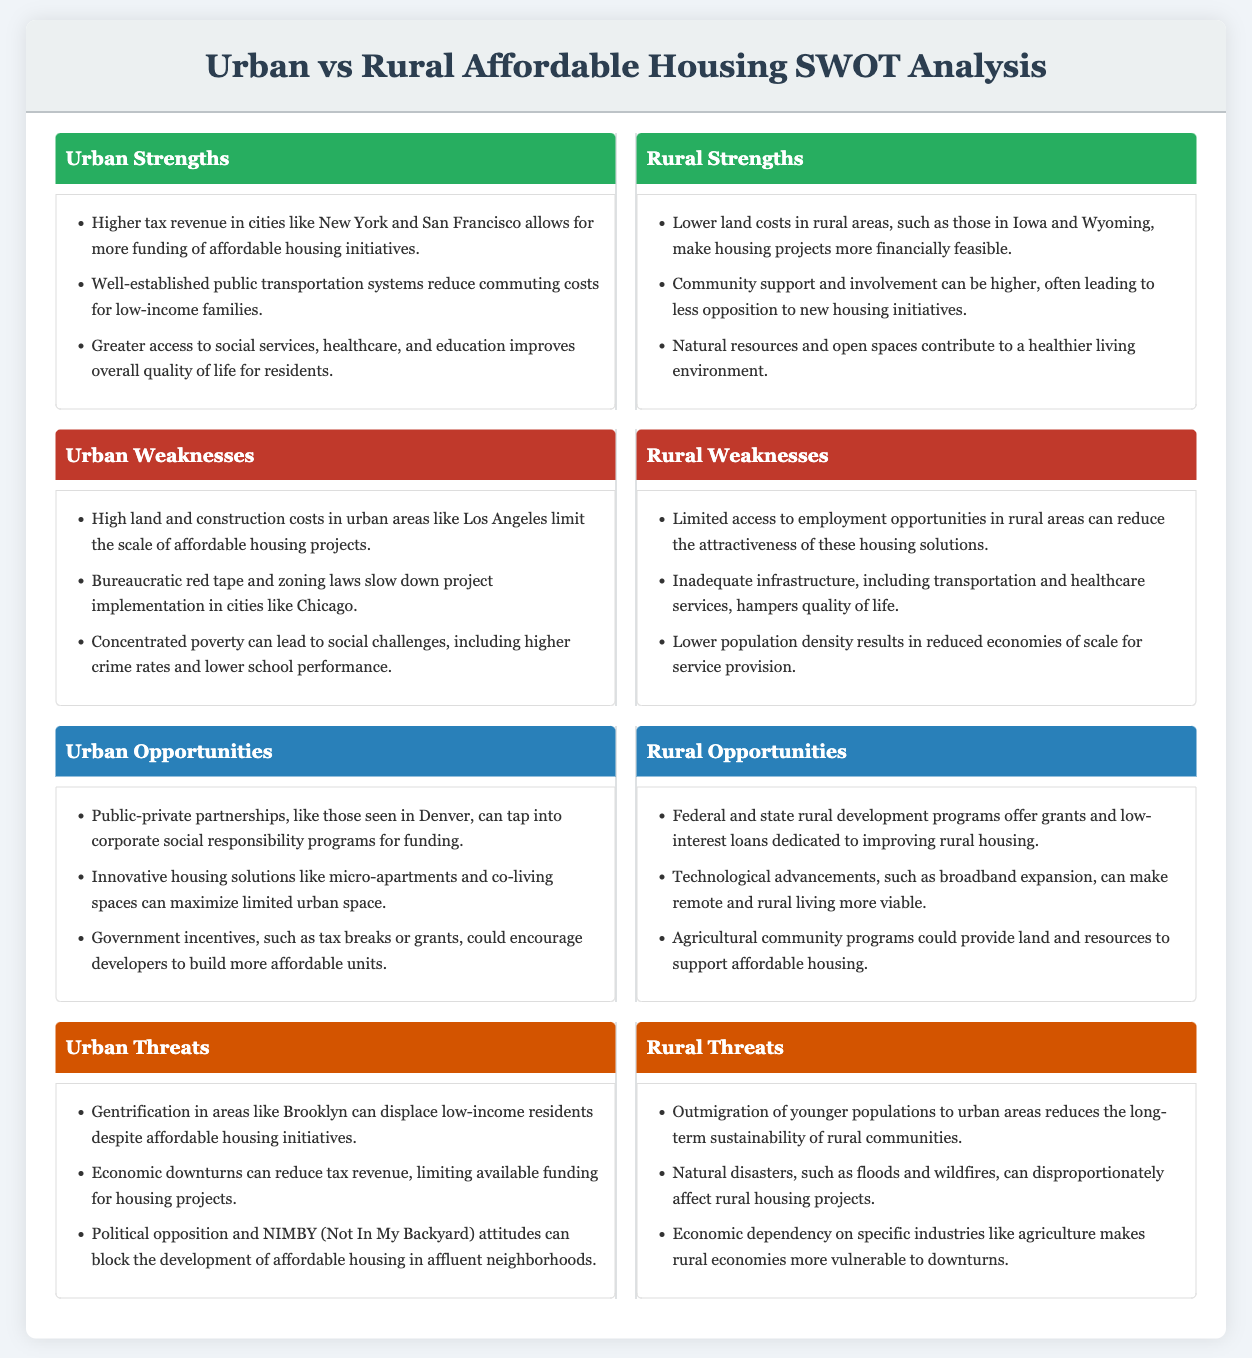What are the strengths of urban areas in affordable housing? The strengths listed under urban areas include higher tax revenue, well-established public transportation, and greater access to social services.
Answer: Higher tax revenue in cities like New York and San Francisco allows for more funding of affordable housing initiatives, well-established public transportation systems reduce commuting costs for low-income families, and greater access to social services, healthcare, and education improves overall quality of life for residents What is a weakness of rural housing initiatives? The weaknesses mentioned for rural areas include limited access to employment opportunities and inadequate infrastructure.
Answer: Limited access to employment opportunities in rural areas can reduce the attractiveness of these housing solutions What urban opportunity can improve affordable housing? The document lists several opportunities for urban areas, including public-private partnerships and innovative housing solutions.
Answer: Public-private partnerships, like those seen in Denver, can tap into corporate social responsibility programs for funding What is a threat faced by urban affordable housing projects? The threats listed for urban areas include gentrification, economic downturns, and political opposition.
Answer: Gentrification in areas like Brooklyn can displace low-income residents despite affordable housing initiatives Which rural strength supports housing initiatives? The strengths associated with rural housing initiatives include lower land costs and community support.
Answer: Lower land costs in rural areas, such as those in Iowa and Wyoming, make housing projects more financially feasible What role does technology play in rural housing opportunities? The opportunities for rural areas include technological advancements that can support better living conditions.
Answer: Technological advancements, such as broadband expansion, can make remote and rural living more viable Which urban challenge involves legal processes? The weaknesses affecting urban areas often mention bureaucratic challenges.
Answer: Bureaucratic red tape and zoning laws slow down project implementation in cities like Chicago How do threats differ between urban and rural areas? The document outlines distinct threats that affect urban and rural affordable housing, with urban areas facing issues like displacement and rural areas facing outmigration.
Answer: Gentrification in areas like Brooklyn can displace low-income residents, while outmigration of younger populations to urban areas reduces the long-term sustainability of rural communities 